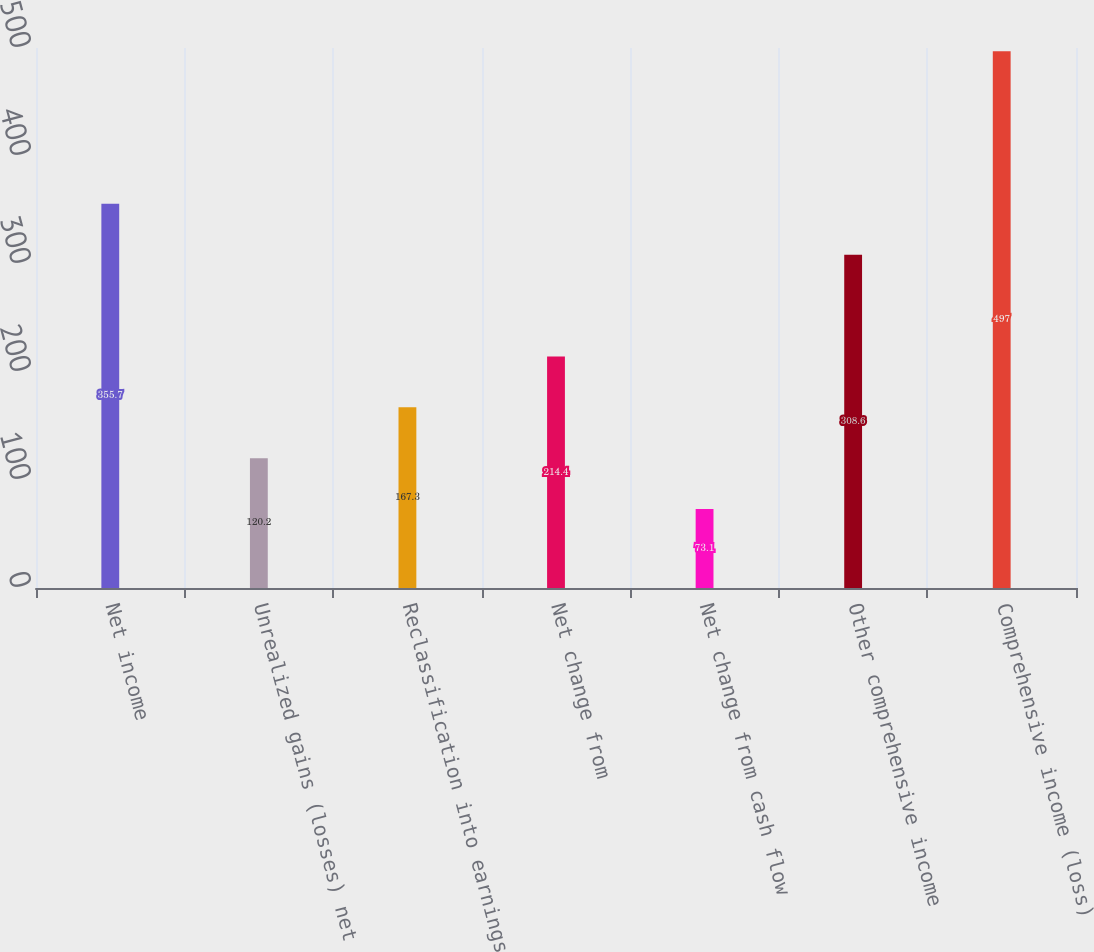Convert chart. <chart><loc_0><loc_0><loc_500><loc_500><bar_chart><fcel>Net income<fcel>Unrealized gains (losses) net<fcel>Reclassification into earnings<fcel>Net change from<fcel>Net change from cash flow<fcel>Other comprehensive income<fcel>Comprehensive income (loss)<nl><fcel>355.7<fcel>120.2<fcel>167.3<fcel>214.4<fcel>73.1<fcel>308.6<fcel>497<nl></chart> 